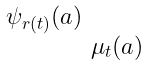<formula> <loc_0><loc_0><loc_500><loc_500>\begin{smallmatrix} \psi _ { r ( t ) } ( a ) \\ & \mu _ { t } ( a ) \end{smallmatrix}</formula> 